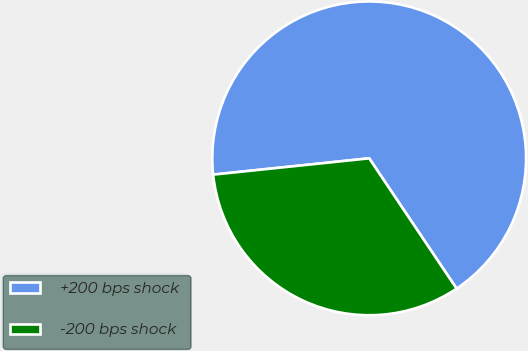<chart> <loc_0><loc_0><loc_500><loc_500><pie_chart><fcel>+200 bps shock<fcel>-200 bps shock<nl><fcel>67.25%<fcel>32.75%<nl></chart> 